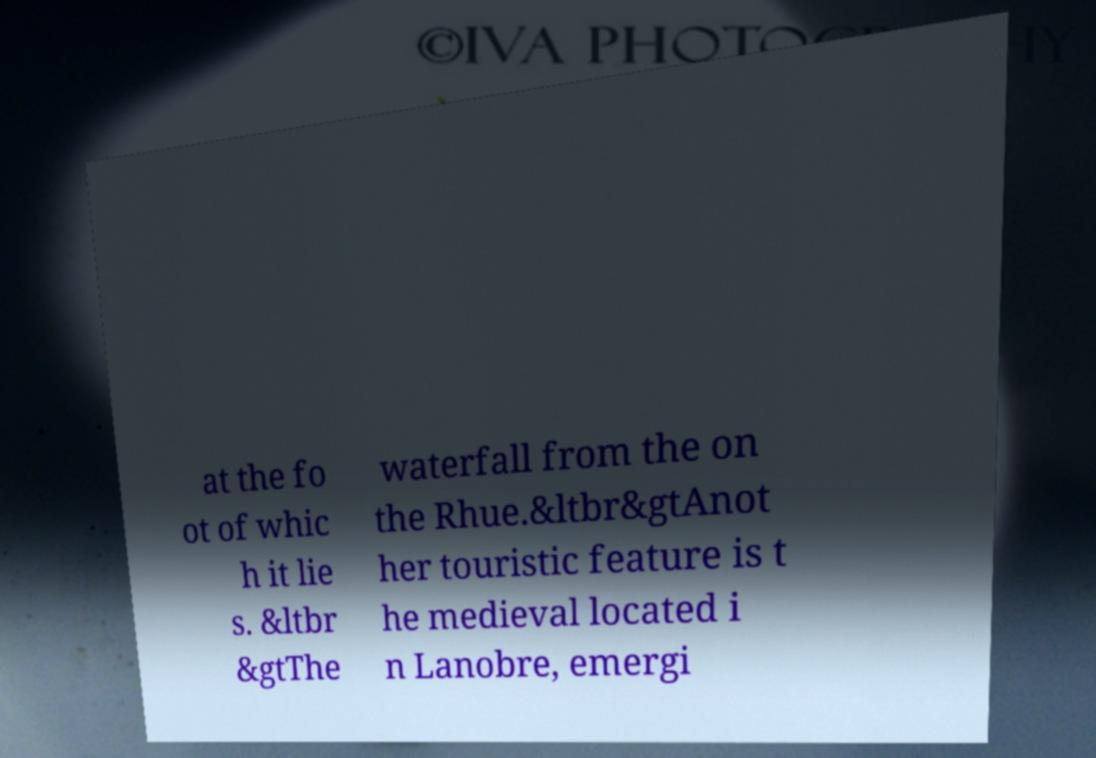Please identify and transcribe the text found in this image. at the fo ot of whic h it lie s. &ltbr &gtThe waterfall from the on the Rhue.&ltbr&gtAnot her touristic feature is t he medieval located i n Lanobre, emergi 